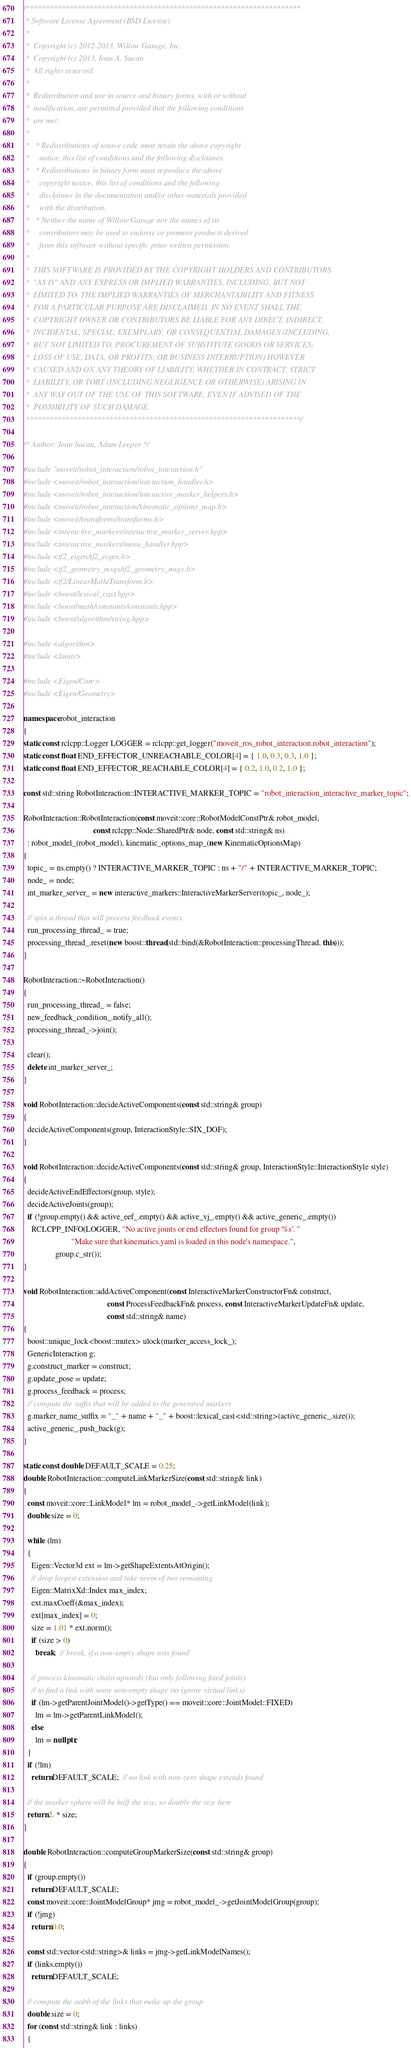<code> <loc_0><loc_0><loc_500><loc_500><_C++_>/*********************************************************************
 * Software License Agreement (BSD License)
 *
 *  Copyright (c) 2012-2013, Willow Garage, Inc.
 *  Copyright (c) 2013, Ioan A. Sucan
 *  All rights reserved.
 *
 *  Redistribution and use in source and binary forms, with or without
 *  modification, are permitted provided that the following conditions
 *  are met:
 *
 *   * Redistributions of source code must retain the above copyright
 *     notice, this list of conditions and the following disclaimer.
 *   * Redistributions in binary form must reproduce the above
 *     copyright notice, this list of conditions and the following
 *     disclaimer in the documentation and/or other materials provided
 *     with the distribution.
 *   * Neither the name of Willow Garage nor the names of its
 *     contributors may be used to endorse or promote products derived
 *     from this software without specific prior written permission.
 *
 *  THIS SOFTWARE IS PROVIDED BY THE COPYRIGHT HOLDERS AND CONTRIBUTORS
 *  "AS IS" AND ANY EXPRESS OR IMPLIED WARRANTIES, INCLUDING, BUT NOT
 *  LIMITED TO, THE IMPLIED WARRANTIES OF MERCHANTABILITY AND FITNESS
 *  FOR A PARTICULAR PURPOSE ARE DISCLAIMED. IN NO EVENT SHALL THE
 *  COPYRIGHT OWNER OR CONTRIBUTORS BE LIABLE FOR ANY DIRECT, INDIRECT,
 *  INCIDENTAL, SPECIAL, EXEMPLARY, OR CONSEQUENTIAL DAMAGES (INCLUDING,
 *  BUT NOT LIMITED TO, PROCUREMENT OF SUBSTITUTE GOODS OR SERVICES;
 *  LOSS OF USE, DATA, OR PROFITS; OR BUSINESS INTERRUPTION) HOWEVER
 *  CAUSED AND ON ANY THEORY OF LIABILITY, WHETHER IN CONTRACT, STRICT
 *  LIABILITY, OR TORT (INCLUDING NEGLIGENCE OR OTHERWISE) ARISING IN
 *  ANY WAY OUT OF THE USE OF THIS SOFTWARE, EVEN IF ADVISED OF THE
 *  POSSIBILITY OF SUCH DAMAGE.
 *********************************************************************/

/* Author: Ioan Sucan, Adam Leeper */

#include "moveit/robot_interaction/robot_interaction.h"
#include <moveit/robot_interaction/interaction_handler.h>
#include <moveit/robot_interaction/interactive_marker_helpers.h>
#include <moveit/robot_interaction/kinematic_options_map.h>
#include <moveit/transforms/transforms.h>
#include <interactive_markers/interactive_marker_server.hpp>
#include <interactive_markers/menu_handler.hpp>
#include <tf2_eigen/tf2_eigen.h>
#include <tf2_geometry_msgs/tf2_geometry_msgs.h>
#include <tf2/LinearMath/Transform.h>
#include <boost/lexical_cast.hpp>
#include <boost/math/constants/constants.hpp>
#include <boost/algorithm/string.hpp>

#include <algorithm>
#include <limits>

#include <Eigen/Core>
#include <Eigen/Geometry>

namespace robot_interaction
{
static const rclcpp::Logger LOGGER = rclcpp::get_logger("moveit_ros_robot_interaction.robot_interaction");
static const float END_EFFECTOR_UNREACHABLE_COLOR[4] = { 1.0, 0.3, 0.3, 1.0 };
static const float END_EFFECTOR_REACHABLE_COLOR[4] = { 0.2, 1.0, 0.2, 1.0 };

const std::string RobotInteraction::INTERACTIVE_MARKER_TOPIC = "robot_interaction_interactive_marker_topic";

RobotInteraction::RobotInteraction(const moveit::core::RobotModelConstPtr& robot_model,
                                   const rclcpp::Node::SharedPtr& node, const std::string& ns)
  : robot_model_(robot_model), kinematic_options_map_(new KinematicOptionsMap)
{
  topic_ = ns.empty() ? INTERACTIVE_MARKER_TOPIC : ns + "/" + INTERACTIVE_MARKER_TOPIC;
  node_ = node;
  int_marker_server_ = new interactive_markers::InteractiveMarkerServer(topic_, node_);

  // spin a thread that will process feedback events
  run_processing_thread_ = true;
  processing_thread_.reset(new boost::thread(std::bind(&RobotInteraction::processingThread, this)));
}

RobotInteraction::~RobotInteraction()
{
  run_processing_thread_ = false;
  new_feedback_condition_.notify_all();
  processing_thread_->join();

  clear();
  delete int_marker_server_;
}

void RobotInteraction::decideActiveComponents(const std::string& group)
{
  decideActiveComponents(group, InteractionStyle::SIX_DOF);
}

void RobotInteraction::decideActiveComponents(const std::string& group, InteractionStyle::InteractionStyle style)
{
  decideActiveEndEffectors(group, style);
  decideActiveJoints(group);
  if (!group.empty() && active_eef_.empty() && active_vj_.empty() && active_generic_.empty())
    RCLCPP_INFO(LOGGER, "No active joints or end effectors found for group '%s'. "
                        "Make sure that kinematics.yaml is loaded in this node's namespace.",
                group.c_str());
}

void RobotInteraction::addActiveComponent(const InteractiveMarkerConstructorFn& construct,
                                          const ProcessFeedbackFn& process, const InteractiveMarkerUpdateFn& update,
                                          const std::string& name)
{
  boost::unique_lock<boost::mutex> ulock(marker_access_lock_);
  GenericInteraction g;
  g.construct_marker = construct;
  g.update_pose = update;
  g.process_feedback = process;
  // compute the suffix that will be added to the generated markers
  g.marker_name_suffix = "_" + name + "_" + boost::lexical_cast<std::string>(active_generic_.size());
  active_generic_.push_back(g);
}

static const double DEFAULT_SCALE = 0.25;
double RobotInteraction::computeLinkMarkerSize(const std::string& link)
{
  const moveit::core::LinkModel* lm = robot_model_->getLinkModel(link);
  double size = 0;

  while (lm)
  {
    Eigen::Vector3d ext = lm->getShapeExtentsAtOrigin();
    // drop largest extension and take norm of two remaining
    Eigen::MatrixXd::Index max_index;
    ext.maxCoeff(&max_index);
    ext[max_index] = 0;
    size = 1.01 * ext.norm();
    if (size > 0)
      break;  // break, if a non-empty shape was found

    // process kinematic chain upwards (but only following fixed joints)
    // to find a link with some non-empty shape (to ignore virtual links)
    if (lm->getParentJointModel()->getType() == moveit::core::JointModel::FIXED)
      lm = lm->getParentLinkModel();
    else
      lm = nullptr;
  }
  if (!lm)
    return DEFAULT_SCALE;  // no link with non-zero shape extends found

  // the marker sphere will be half the size, so double the size here
  return 2. * size;
}

double RobotInteraction::computeGroupMarkerSize(const std::string& group)
{
  if (group.empty())
    return DEFAULT_SCALE;
  const moveit::core::JointModelGroup* jmg = robot_model_->getJointModelGroup(group);
  if (!jmg)
    return 0.0;

  const std::vector<std::string>& links = jmg->getLinkModelNames();
  if (links.empty())
    return DEFAULT_SCALE;

  // compute the aabb of the links that make up the group
  double size = 0;
  for (const std::string& link : links)
  {</code> 